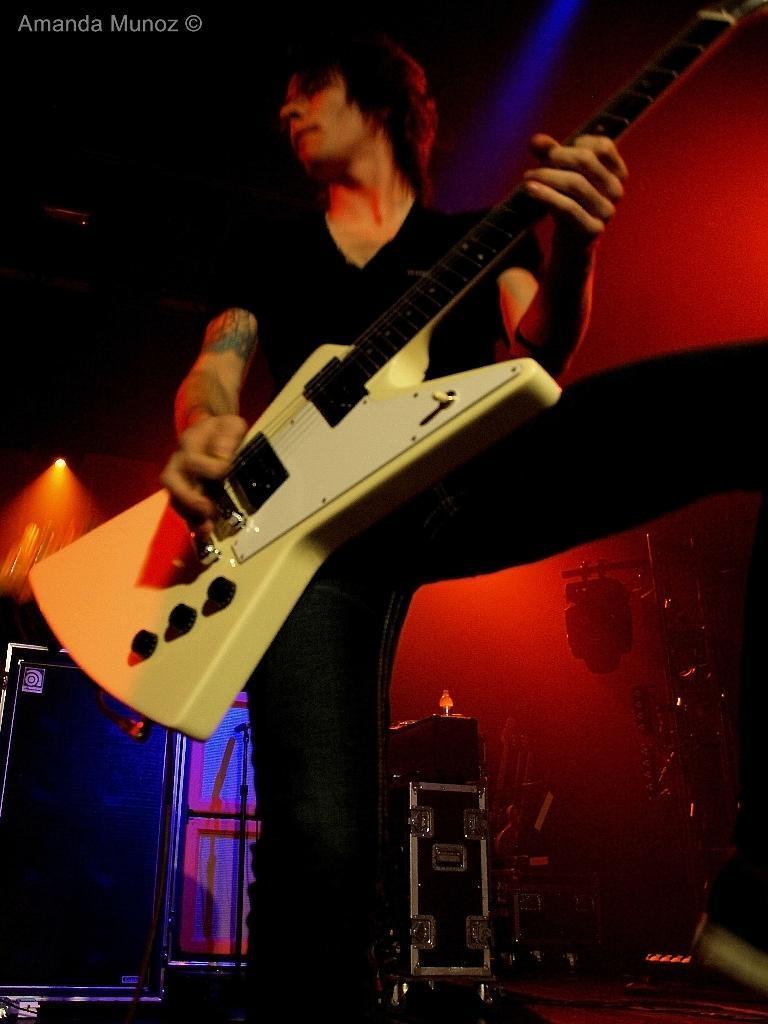Can you describe this image briefly? The picture shows that there is a person standing in the center and he is playing a guitar. This is a speaker which is in the bottom left side. Here we can observe a musical instrument which is in the bottom right side. 